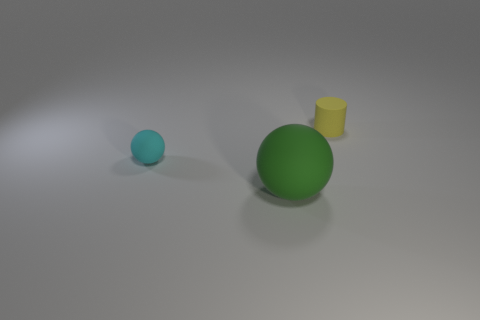What is the largest object in the image? The largest object in the image is the green sphere. 